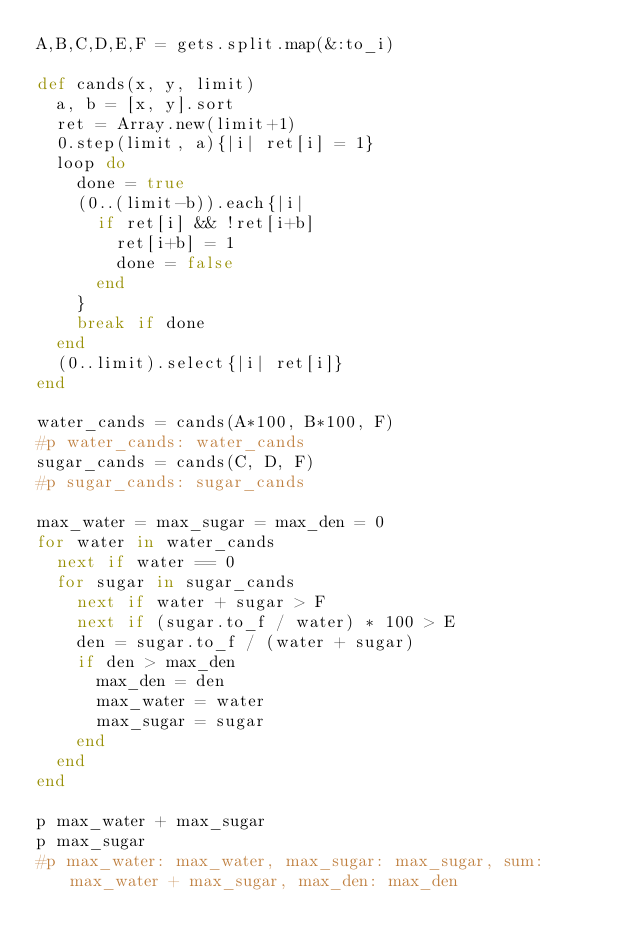Convert code to text. <code><loc_0><loc_0><loc_500><loc_500><_Ruby_>A,B,C,D,E,F = gets.split.map(&:to_i)

def cands(x, y, limit)
  a, b = [x, y].sort
  ret = Array.new(limit+1)
  0.step(limit, a){|i| ret[i] = 1}
  loop do
    done = true
    (0..(limit-b)).each{|i| 
      if ret[i] && !ret[i+b]
        ret[i+b] = 1
        done = false
      end
    }
    break if done
  end
  (0..limit).select{|i| ret[i]}
end

water_cands = cands(A*100, B*100, F)
#p water_cands: water_cands
sugar_cands = cands(C, D, F)
#p sugar_cands: sugar_cands

max_water = max_sugar = max_den = 0
for water in water_cands
  next if water == 0
  for sugar in sugar_cands
    next if water + sugar > F
    next if (sugar.to_f / water) * 100 > E
    den = sugar.to_f / (water + sugar)
    if den > max_den
      max_den = den
      max_water = water
      max_sugar = sugar
    end
  end
end

p max_water + max_sugar
p max_sugar
#p max_water: max_water, max_sugar: max_sugar, sum: max_water + max_sugar, max_den: max_den
</code> 